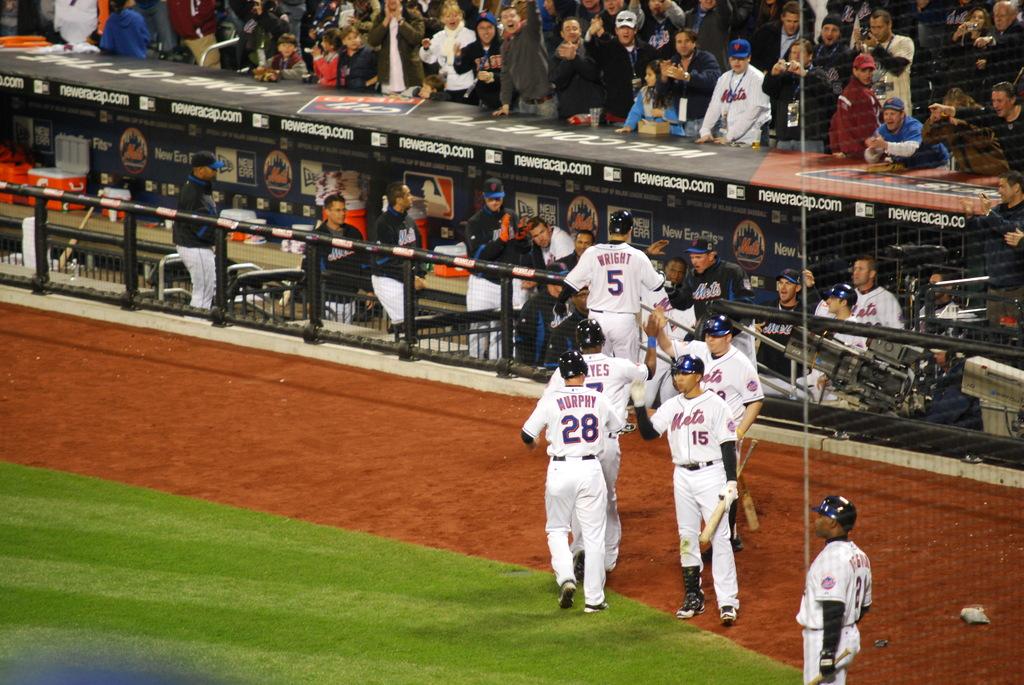What is the number of the player furthest away?
Offer a terse response. 5. 